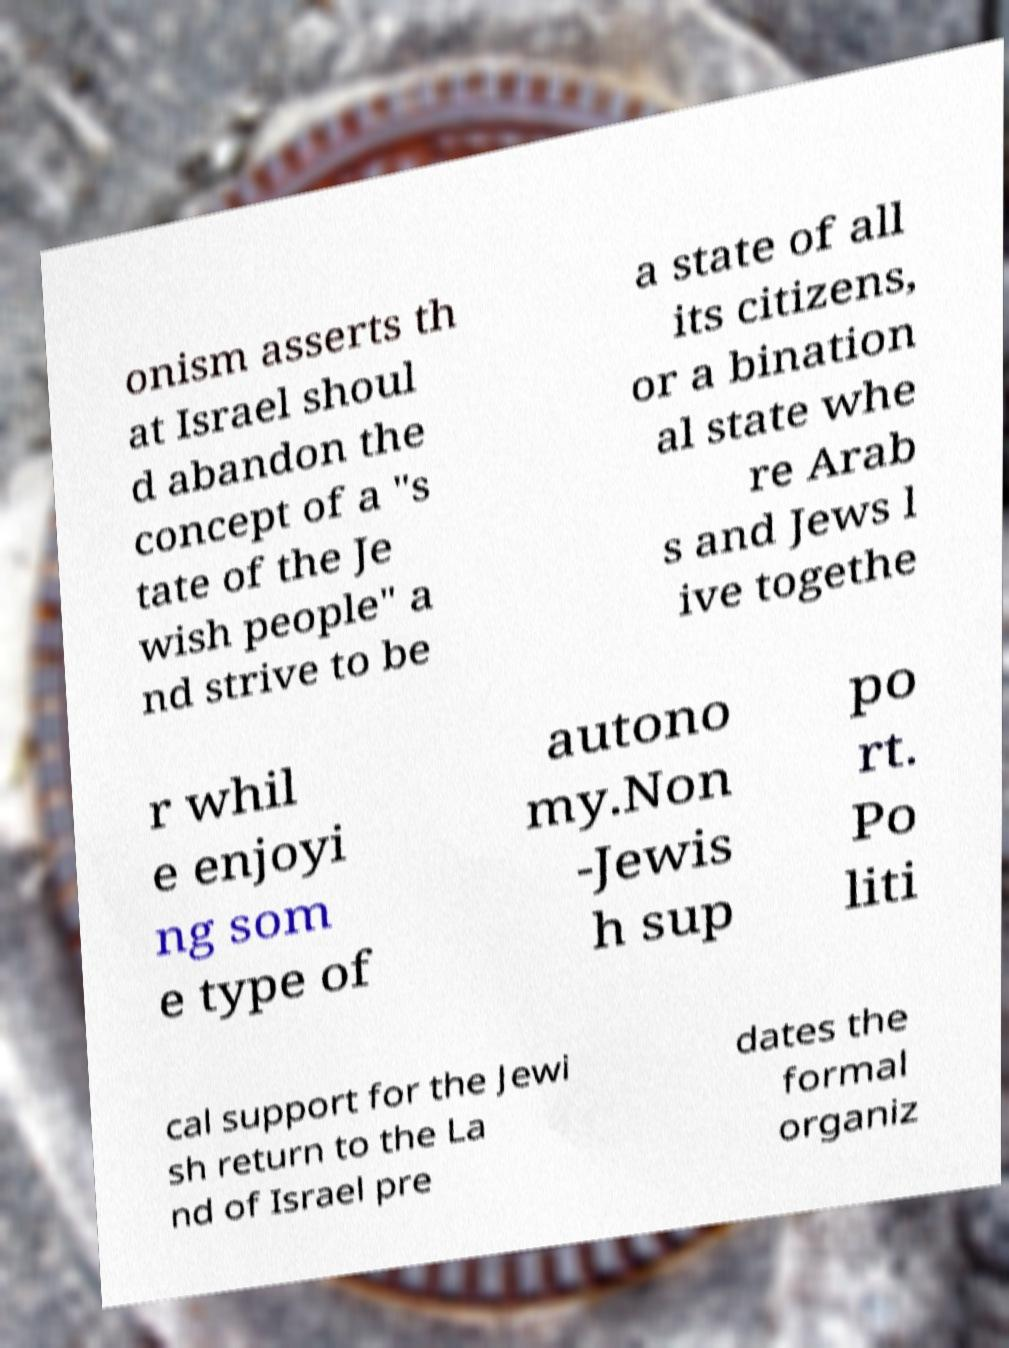What messages or text are displayed in this image? I need them in a readable, typed format. onism asserts th at Israel shoul d abandon the concept of a "s tate of the Je wish people" a nd strive to be a state of all its citizens, or a bination al state whe re Arab s and Jews l ive togethe r whil e enjoyi ng som e type of autono my.Non -Jewis h sup po rt. Po liti cal support for the Jewi sh return to the La nd of Israel pre dates the formal organiz 